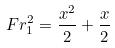Convert formula to latex. <formula><loc_0><loc_0><loc_500><loc_500>F r _ { 1 } ^ { 2 } = \frac { x ^ { 2 } } { 2 } + \frac { x } { 2 }</formula> 